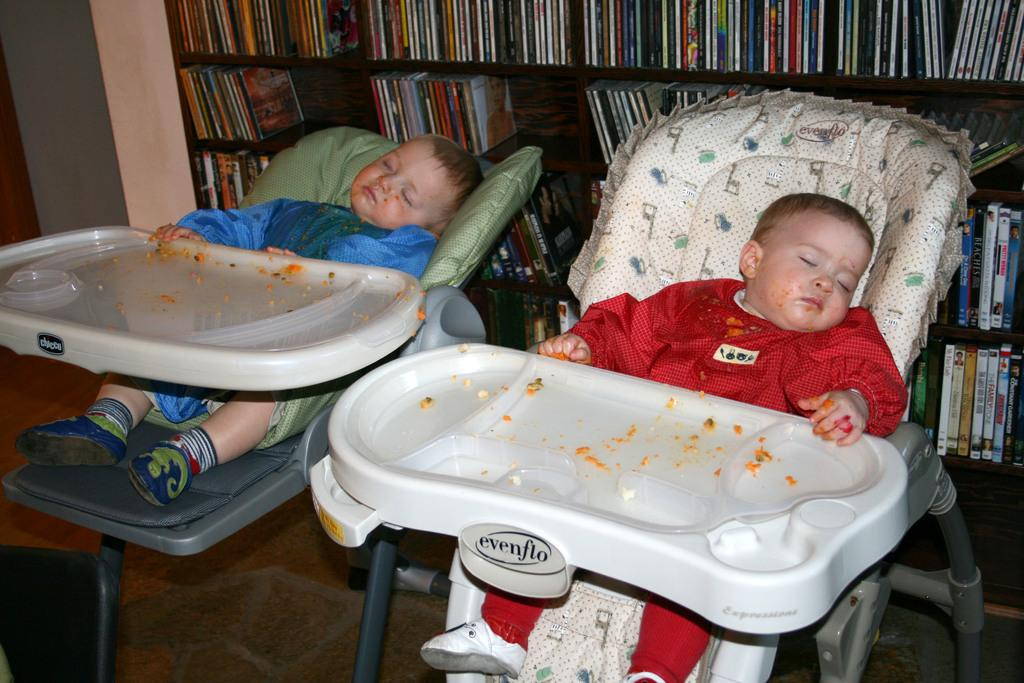How many babies are in the image? There are two babies in the image. What are the babies doing in the image? Both babies are sleeping. Where are the babies located in the image? The babies are in strollers. What colors are the dresses of the babies? One baby is wearing a red dress, and the other baby is wearing a blue dress. What can be seen behind the strollers in the image? There is a book rack behind the strollers. What type of glass can be seen in the image? There is no glass present in the image; it features two babies sleeping in strollers with a book rack behind them. 